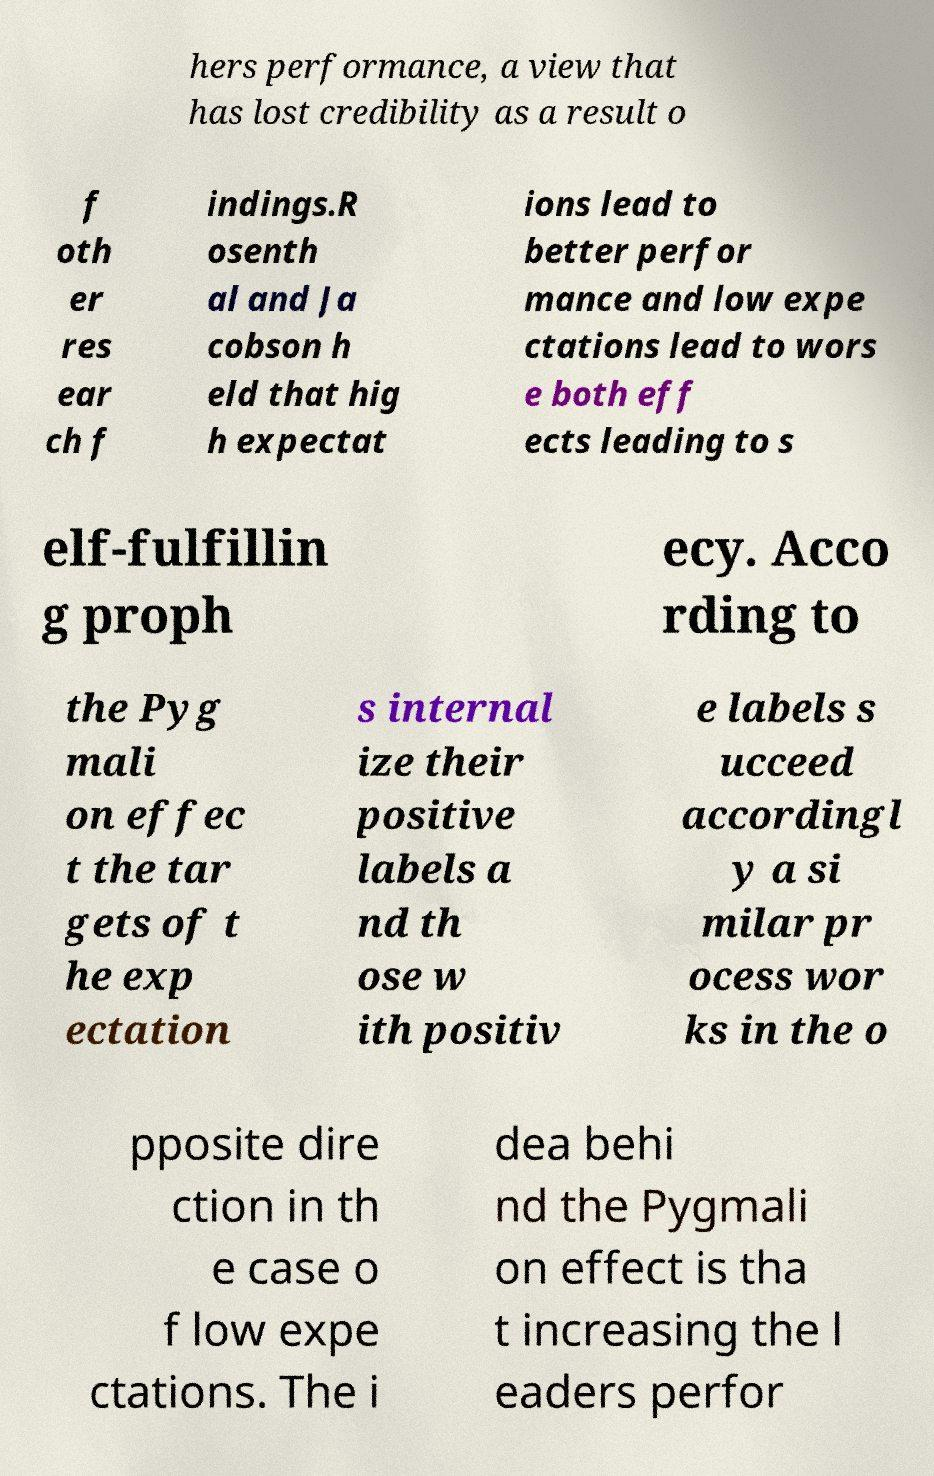There's text embedded in this image that I need extracted. Can you transcribe it verbatim? hers performance, a view that has lost credibility as a result o f oth er res ear ch f indings.R osenth al and Ja cobson h eld that hig h expectat ions lead to better perfor mance and low expe ctations lead to wors e both eff ects leading to s elf-fulfillin g proph ecy. Acco rding to the Pyg mali on effec t the tar gets of t he exp ectation s internal ize their positive labels a nd th ose w ith positiv e labels s ucceed accordingl y a si milar pr ocess wor ks in the o pposite dire ction in th e case o f low expe ctations. The i dea behi nd the Pygmali on effect is tha t increasing the l eaders perfor 